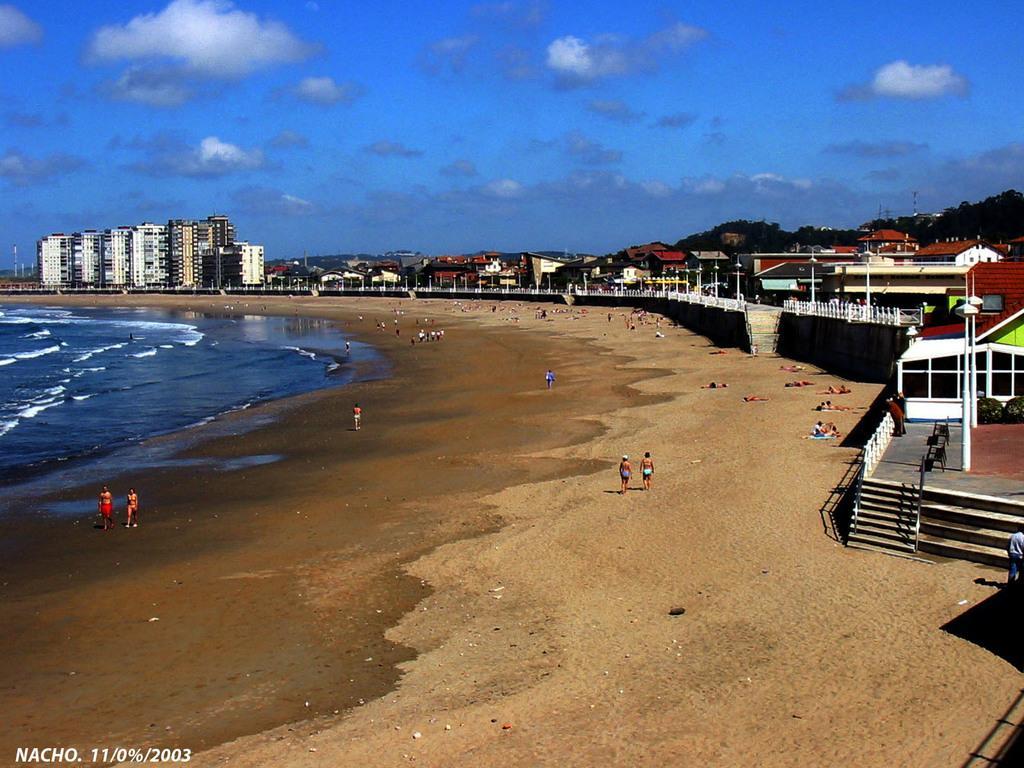In one or two sentences, can you explain what this image depicts? This picture shows buildings and trees and we see few people standing and few are walking and few are laying on the seashore and we see water and text at the bottom left corner and we see a cloudy sky. 